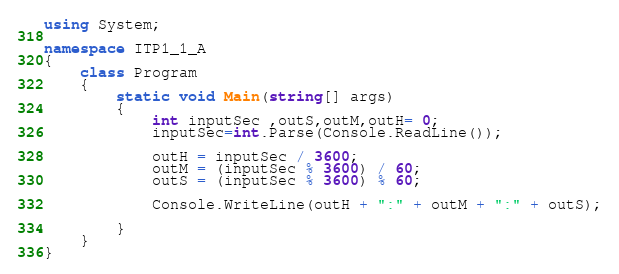<code> <loc_0><loc_0><loc_500><loc_500><_C#_>using System;

namespace ITP1_1_A
{
    class Program
    {
        static void Main(string[] args)
        {
            int inputSec ,outS,outM,outH= 0;
            inputSec=int.Parse(Console.ReadLine());

            outH = inputSec / 3600;
            outM = (inputSec % 3600) / 60;
            outS = (inputSec % 3600) % 60;

            Console.WriteLine(outH + ":" + outM + ":" + outS);
           
        }
    }
}

</code> 